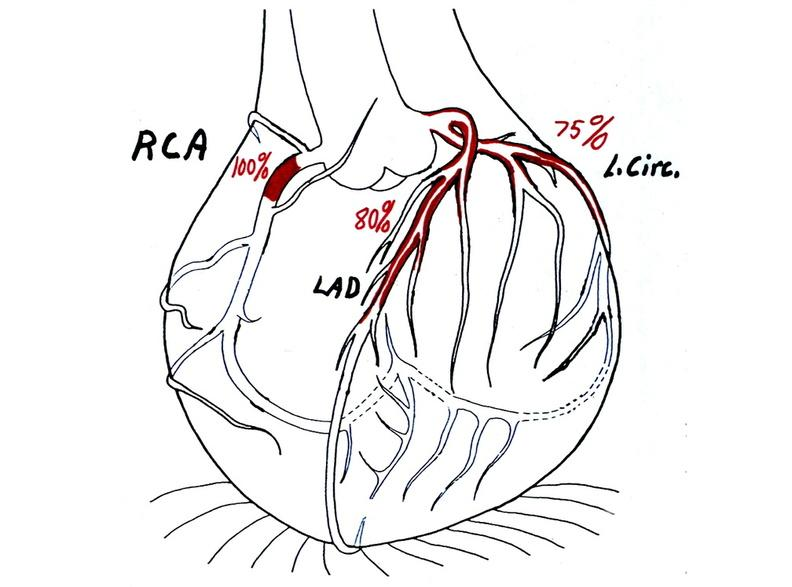where is this area in the body?
Answer the question using a single word or phrase. Heart 